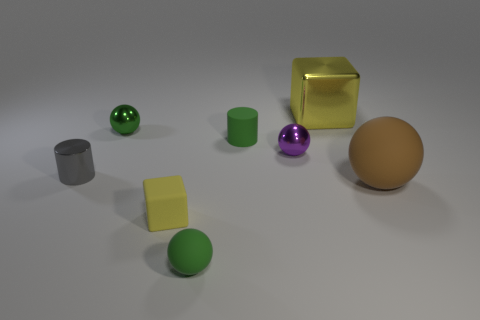The yellow thing right of the green rubber thing in front of the big brown matte thing is what shape?
Provide a short and direct response. Cube. Is the color of the rubber cylinder the same as the tiny object that is on the right side of the tiny green rubber cylinder?
Keep it short and to the point. No. There is a gray shiny thing; what shape is it?
Offer a very short reply. Cylinder. What size is the rubber sphere in front of the small cube to the right of the green metallic thing?
Give a very brief answer. Small. Is the number of small rubber spheres in front of the brown sphere the same as the number of gray cylinders that are in front of the gray thing?
Make the answer very short. No. What material is the small thing that is right of the yellow matte cube and in front of the large brown thing?
Your answer should be very brief. Rubber. There is a green shiny object; does it have the same size as the rubber thing that is to the right of the small purple metallic object?
Provide a succinct answer. No. How many other things are the same color as the large rubber thing?
Provide a succinct answer. 0. Are there more large yellow metallic cubes that are on the left side of the yellow rubber block than small purple metallic things?
Your answer should be compact. No. What color is the metal sphere that is to the right of the rubber sphere to the left of the yellow block that is behind the green cylinder?
Provide a succinct answer. Purple. 